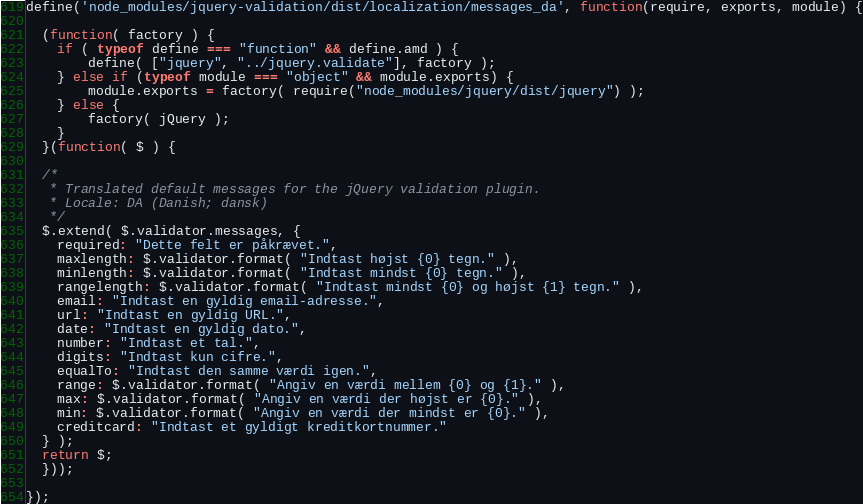Convert code to text. <code><loc_0><loc_0><loc_500><loc_500><_JavaScript_>define('node_modules/jquery-validation/dist/localization/messages_da', function(require, exports, module) {

  (function( factory ) {
  	if ( typeof define === "function" && define.amd ) {
  		define( ["jquery", "../jquery.validate"], factory );
  	} else if (typeof module === "object" && module.exports) {
  		module.exports = factory( require("node_modules/jquery/dist/jquery") );
  	} else {
  		factory( jQuery );
  	}
  }(function( $ ) {
  
  /*
   * Translated default messages for the jQuery validation plugin.
   * Locale: DA (Danish; dansk)
   */
  $.extend( $.validator.messages, {
  	required: "Dette felt er påkrævet.",
  	maxlength: $.validator.format( "Indtast højst {0} tegn." ),
  	minlength: $.validator.format( "Indtast mindst {0} tegn." ),
  	rangelength: $.validator.format( "Indtast mindst {0} og højst {1} tegn." ),
  	email: "Indtast en gyldig email-adresse.",
  	url: "Indtast en gyldig URL.",
  	date: "Indtast en gyldig dato.",
  	number: "Indtast et tal.",
  	digits: "Indtast kun cifre.",
  	equalTo: "Indtast den samme værdi igen.",
  	range: $.validator.format( "Angiv en værdi mellem {0} og {1}." ),
  	max: $.validator.format( "Angiv en værdi der højst er {0}." ),
  	min: $.validator.format( "Angiv en værdi der mindst er {0}." ),
  	creditcard: "Indtast et gyldigt kreditkortnummer."
  } );
  return $;
  }));

});
</code> 